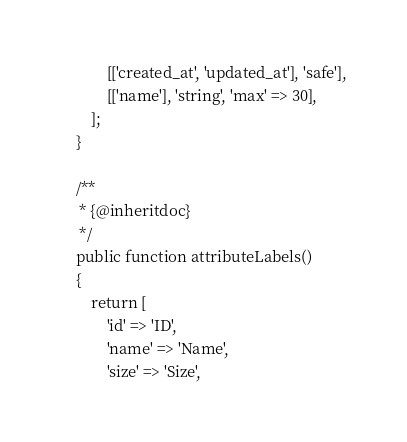Convert code to text. <code><loc_0><loc_0><loc_500><loc_500><_PHP_>            [['created_at', 'updated_at'], 'safe'],
            [['name'], 'string', 'max' => 30],
        ];
    }

    /**
     * {@inheritdoc}
     */
    public function attributeLabels()
    {
        return [
            'id' => 'ID',
            'name' => 'Name',
            'size' => 'Size',</code> 